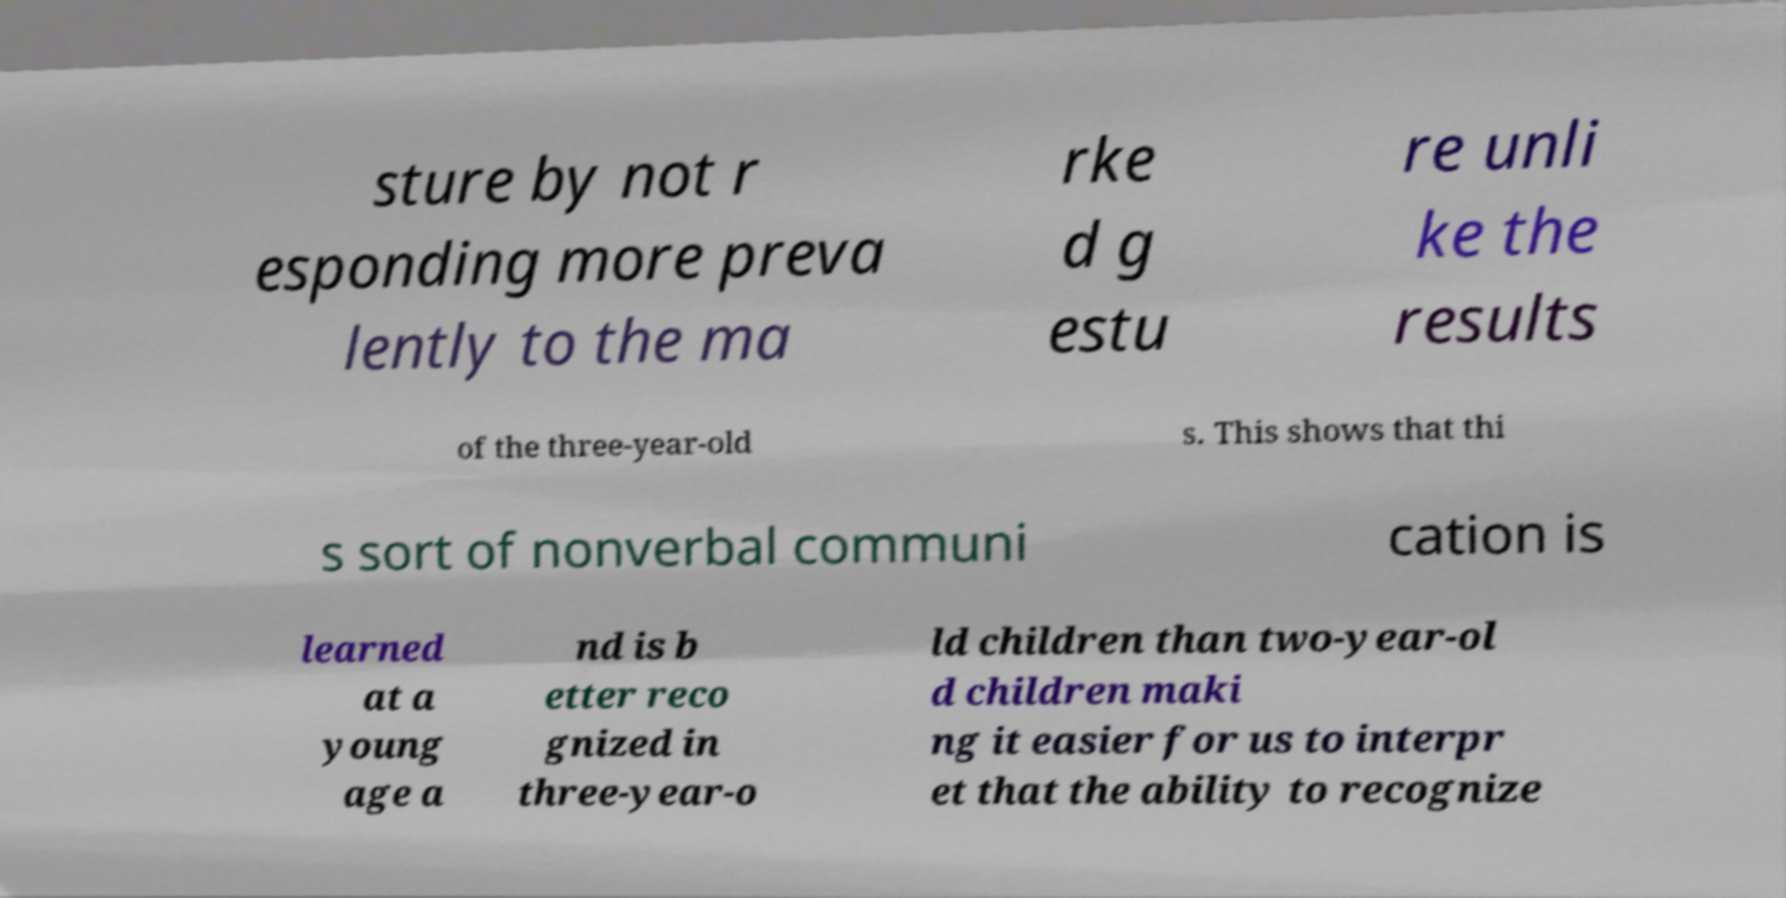There's text embedded in this image that I need extracted. Can you transcribe it verbatim? sture by not r esponding more preva lently to the ma rke d g estu re unli ke the results of the three-year-old s. This shows that thi s sort of nonverbal communi cation is learned at a young age a nd is b etter reco gnized in three-year-o ld children than two-year-ol d children maki ng it easier for us to interpr et that the ability to recognize 